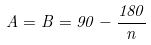Convert formula to latex. <formula><loc_0><loc_0><loc_500><loc_500>A = B = 9 0 - \frac { 1 8 0 } { n }</formula> 